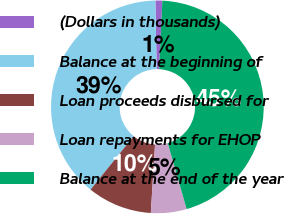Convert chart to OTSL. <chart><loc_0><loc_0><loc_500><loc_500><pie_chart><fcel>(Dollars in thousands)<fcel>Balance at the beginning of<fcel>Loan proceeds disbursed for<fcel>Loan repayments for EHOP<fcel>Balance at the end of the year<nl><fcel>1.05%<fcel>38.89%<fcel>9.83%<fcel>5.42%<fcel>44.81%<nl></chart> 